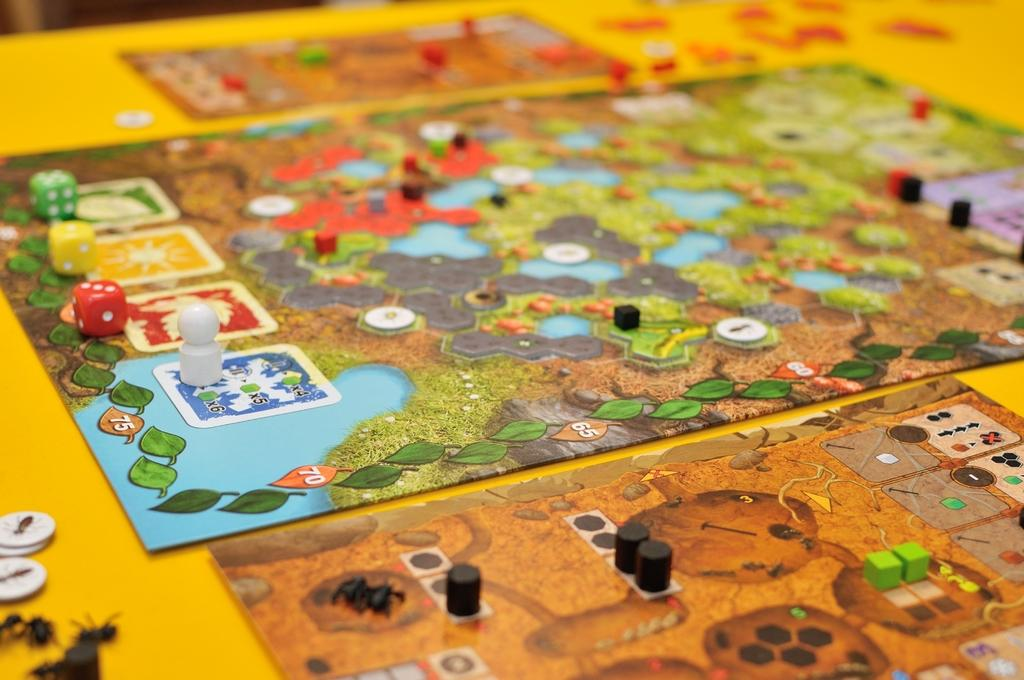What type of games are featured in the image? The image contains board games. What small objects are used in these games? There are dice in the image. What else can be seen in the image that might be used in board games? There are coins in the image, as well as other objects related to board games. What type of soap is being used to clean the property in the image? There is no soap, property, or cleaning activity present in the image. The image features board games and related objects. 